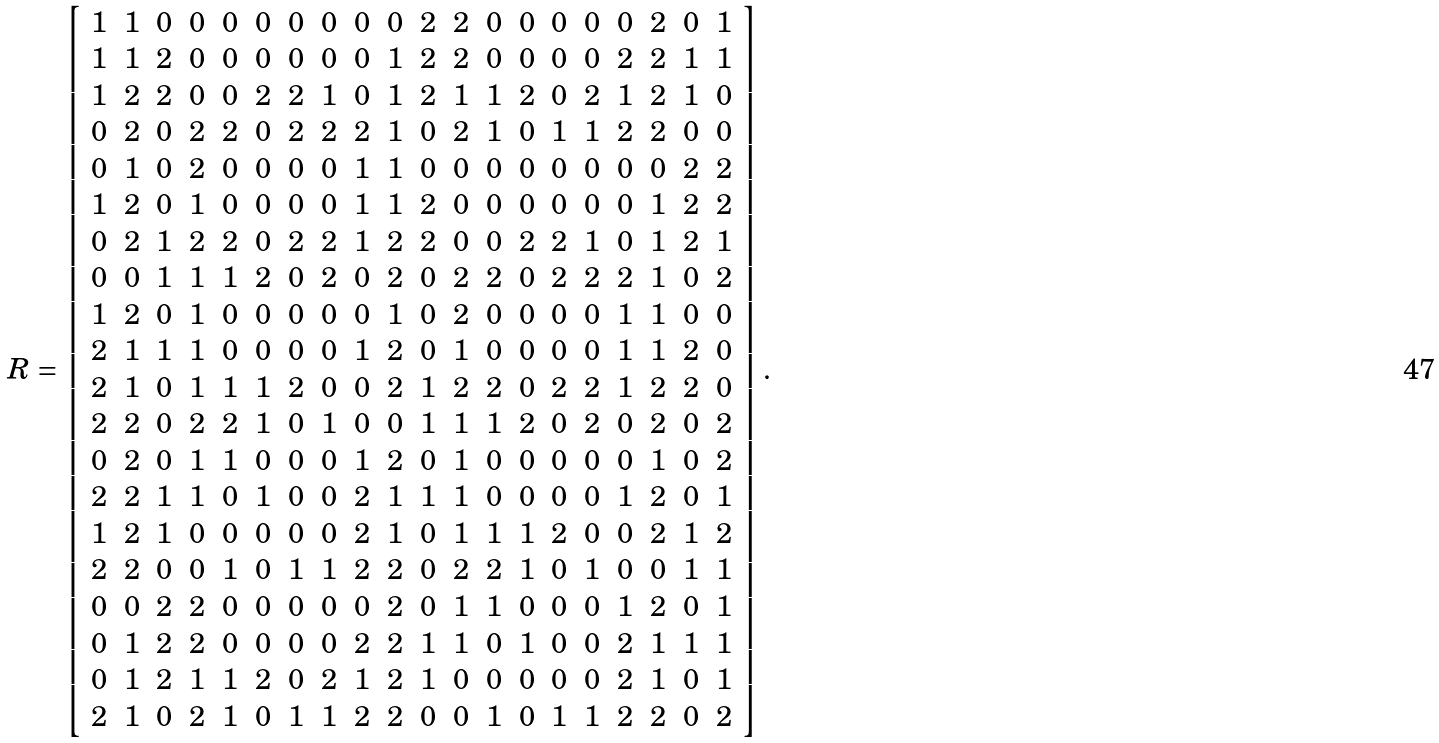Convert formula to latex. <formula><loc_0><loc_0><loc_500><loc_500>R = \left [ \begin{array} { c c c c c c c c c c c c c c c c c c c c } 1 & 1 & 0 & 0 & 0 & 0 & 0 & 0 & 0 & 0 & 2 & 2 & 0 & 0 & 0 & 0 & 0 & 2 & 0 & 1 \\ 1 & 1 & 2 & 0 & 0 & 0 & 0 & 0 & 0 & 1 & 2 & 2 & 0 & 0 & 0 & 0 & 2 & 2 & 1 & 1 \\ 1 & 2 & 2 & 0 & 0 & 2 & 2 & 1 & 0 & 1 & 2 & 1 & 1 & 2 & 0 & 2 & 1 & 2 & 1 & 0 \\ 0 & 2 & 0 & 2 & 2 & 0 & 2 & 2 & 2 & 1 & 0 & 2 & 1 & 0 & 1 & 1 & 2 & 2 & 0 & 0 \\ 0 & 1 & 0 & 2 & 0 & 0 & 0 & 0 & 1 & 1 & 0 & 0 & 0 & 0 & 0 & 0 & 0 & 0 & 2 & 2 \\ 1 & 2 & 0 & 1 & 0 & 0 & 0 & 0 & 1 & 1 & 2 & 0 & 0 & 0 & 0 & 0 & 0 & 1 & 2 & 2 \\ 0 & 2 & 1 & 2 & 2 & 0 & 2 & 2 & 1 & 2 & 2 & 0 & 0 & 2 & 2 & 1 & 0 & 1 & 2 & 1 \\ 0 & 0 & 1 & 1 & 1 & 2 & 0 & 2 & 0 & 2 & 0 & 2 & 2 & 0 & 2 & 2 & 2 & 1 & 0 & 2 \\ 1 & 2 & 0 & 1 & 0 & 0 & 0 & 0 & 0 & 1 & 0 & 2 & 0 & 0 & 0 & 0 & 1 & 1 & 0 & 0 \\ 2 & 1 & 1 & 1 & 0 & 0 & 0 & 0 & 1 & 2 & 0 & 1 & 0 & 0 & 0 & 0 & 1 & 1 & 2 & 0 \\ 2 & 1 & 0 & 1 & 1 & 1 & 2 & 0 & 0 & 2 & 1 & 2 & 2 & 0 & 2 & 2 & 1 & 2 & 2 & 0 \\ 2 & 2 & 0 & 2 & 2 & 1 & 0 & 1 & 0 & 0 & 1 & 1 & 1 & 2 & 0 & 2 & 0 & 2 & 0 & 2 \\ 0 & 2 & 0 & 1 & 1 & 0 & 0 & 0 & 1 & 2 & 0 & 1 & 0 & 0 & 0 & 0 & 0 & 1 & 0 & 2 \\ 2 & 2 & 1 & 1 & 0 & 1 & 0 & 0 & 2 & 1 & 1 & 1 & 0 & 0 & 0 & 0 & 1 & 2 & 0 & 1 \\ 1 & 2 & 1 & 0 & 0 & 0 & 0 & 0 & 2 & 1 & 0 & 1 & 1 & 1 & 2 & 0 & 0 & 2 & 1 & 2 \\ 2 & 2 & 0 & 0 & 1 & 0 & 1 & 1 & 2 & 2 & 0 & 2 & 2 & 1 & 0 & 1 & 0 & 0 & 1 & 1 \\ 0 & 0 & 2 & 2 & 0 & 0 & 0 & 0 & 0 & 2 & 0 & 1 & 1 & 0 & 0 & 0 & 1 & 2 & 0 & 1 \\ 0 & 1 & 2 & 2 & 0 & 0 & 0 & 0 & 2 & 2 & 1 & 1 & 0 & 1 & 0 & 0 & 2 & 1 & 1 & 1 \\ 0 & 1 & 2 & 1 & 1 & 2 & 0 & 2 & 1 & 2 & 1 & 0 & 0 & 0 & 0 & 0 & 2 & 1 & 0 & 1 \\ 2 & 1 & 0 & 2 & 1 & 0 & 1 & 1 & 2 & 2 & 0 & 0 & 1 & 0 & 1 & 1 & 2 & 2 & 0 & 2 \end{array} \right ] .</formula> 